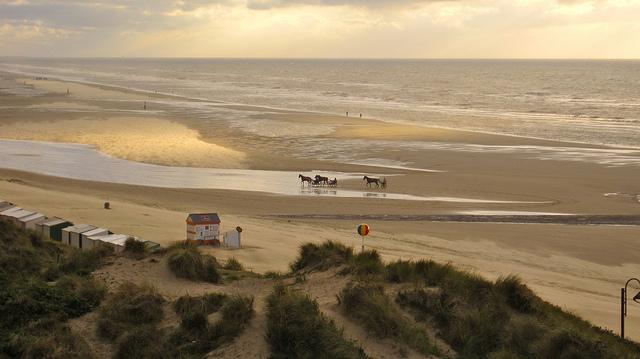Is that water in the distance?
Give a very brief answer. Yes. What type of animals are on the beach?
Be succinct. Horses. Was this picture taken in the morning?
Short answer required. Yes. 